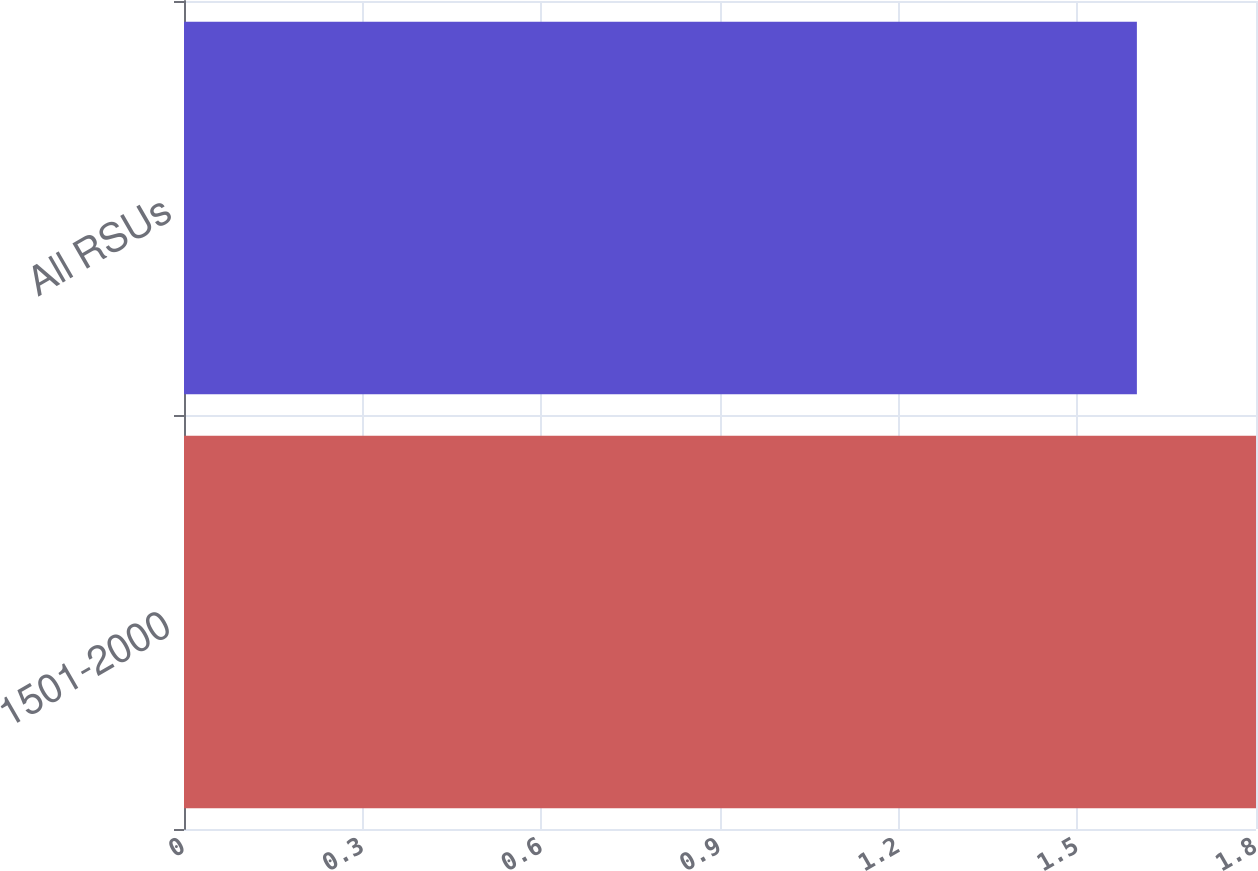Convert chart to OTSL. <chart><loc_0><loc_0><loc_500><loc_500><bar_chart><fcel>1501-2000<fcel>All RSUs<nl><fcel>1.8<fcel>1.6<nl></chart> 